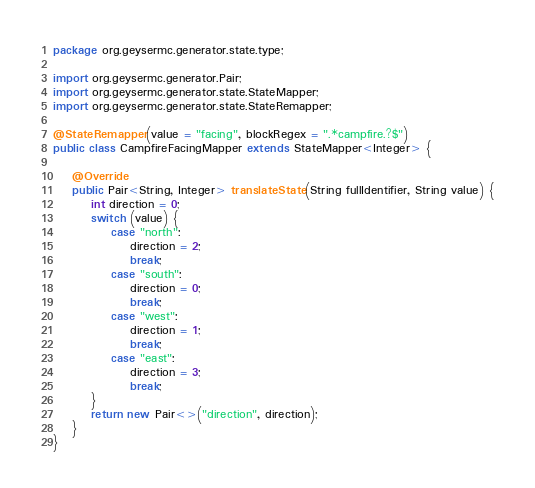<code> <loc_0><loc_0><loc_500><loc_500><_Java_>package org.geysermc.generator.state.type;

import org.geysermc.generator.Pair;
import org.geysermc.generator.state.StateMapper;
import org.geysermc.generator.state.StateRemapper;

@StateRemapper(value = "facing", blockRegex = ".*campfire.?$")
public class CampfireFacingMapper extends StateMapper<Integer> {

    @Override
    public Pair<String, Integer> translateState(String fullIdentifier, String value) {
        int direction = 0;
        switch (value) {
            case "north":
                direction = 2;
                break;
            case "south":
                direction = 0;
                break;
            case "west":
                direction = 1;
                break;
            case "east":
                direction = 3;
                break;
        }
        return new Pair<>("direction", direction);
    }
}
</code> 